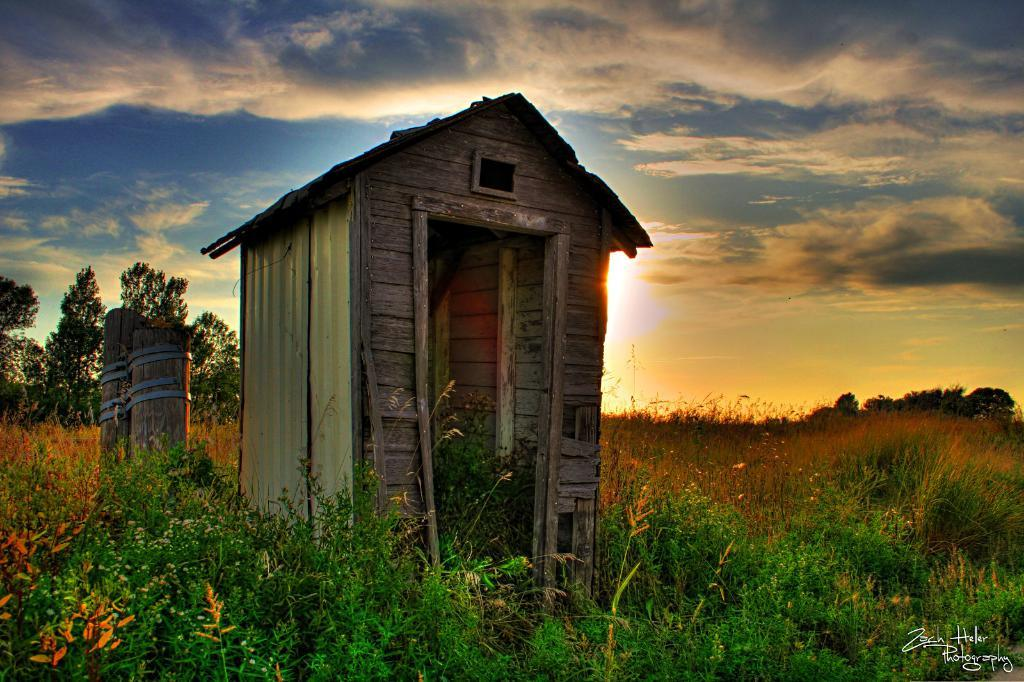What type of structure is present in the image? There is a shed in the image. What other objects or elements can be seen in the image? There are plants, wooden logs, trees, and some text in the bottom right corner of the image. What is visible in the background of the image? The sky with clouds is visible in the background of the image. Where is the library located in the image? There is no library present in the image. What type of wheel can be seen in the image? There is no wheel present in the image. 